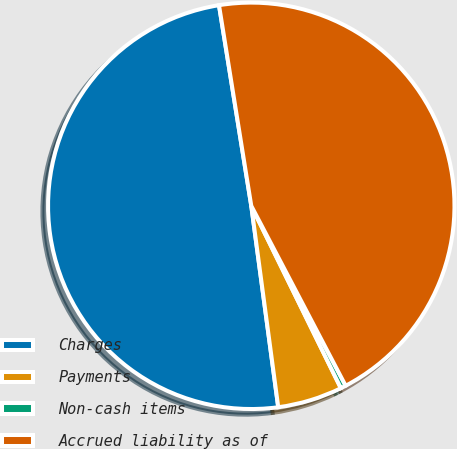Convert chart to OTSL. <chart><loc_0><loc_0><loc_500><loc_500><pie_chart><fcel>Charges<fcel>Payments<fcel>Non-cash items<fcel>Accrued liability as of<nl><fcel>49.58%<fcel>5.15%<fcel>0.42%<fcel>44.85%<nl></chart> 